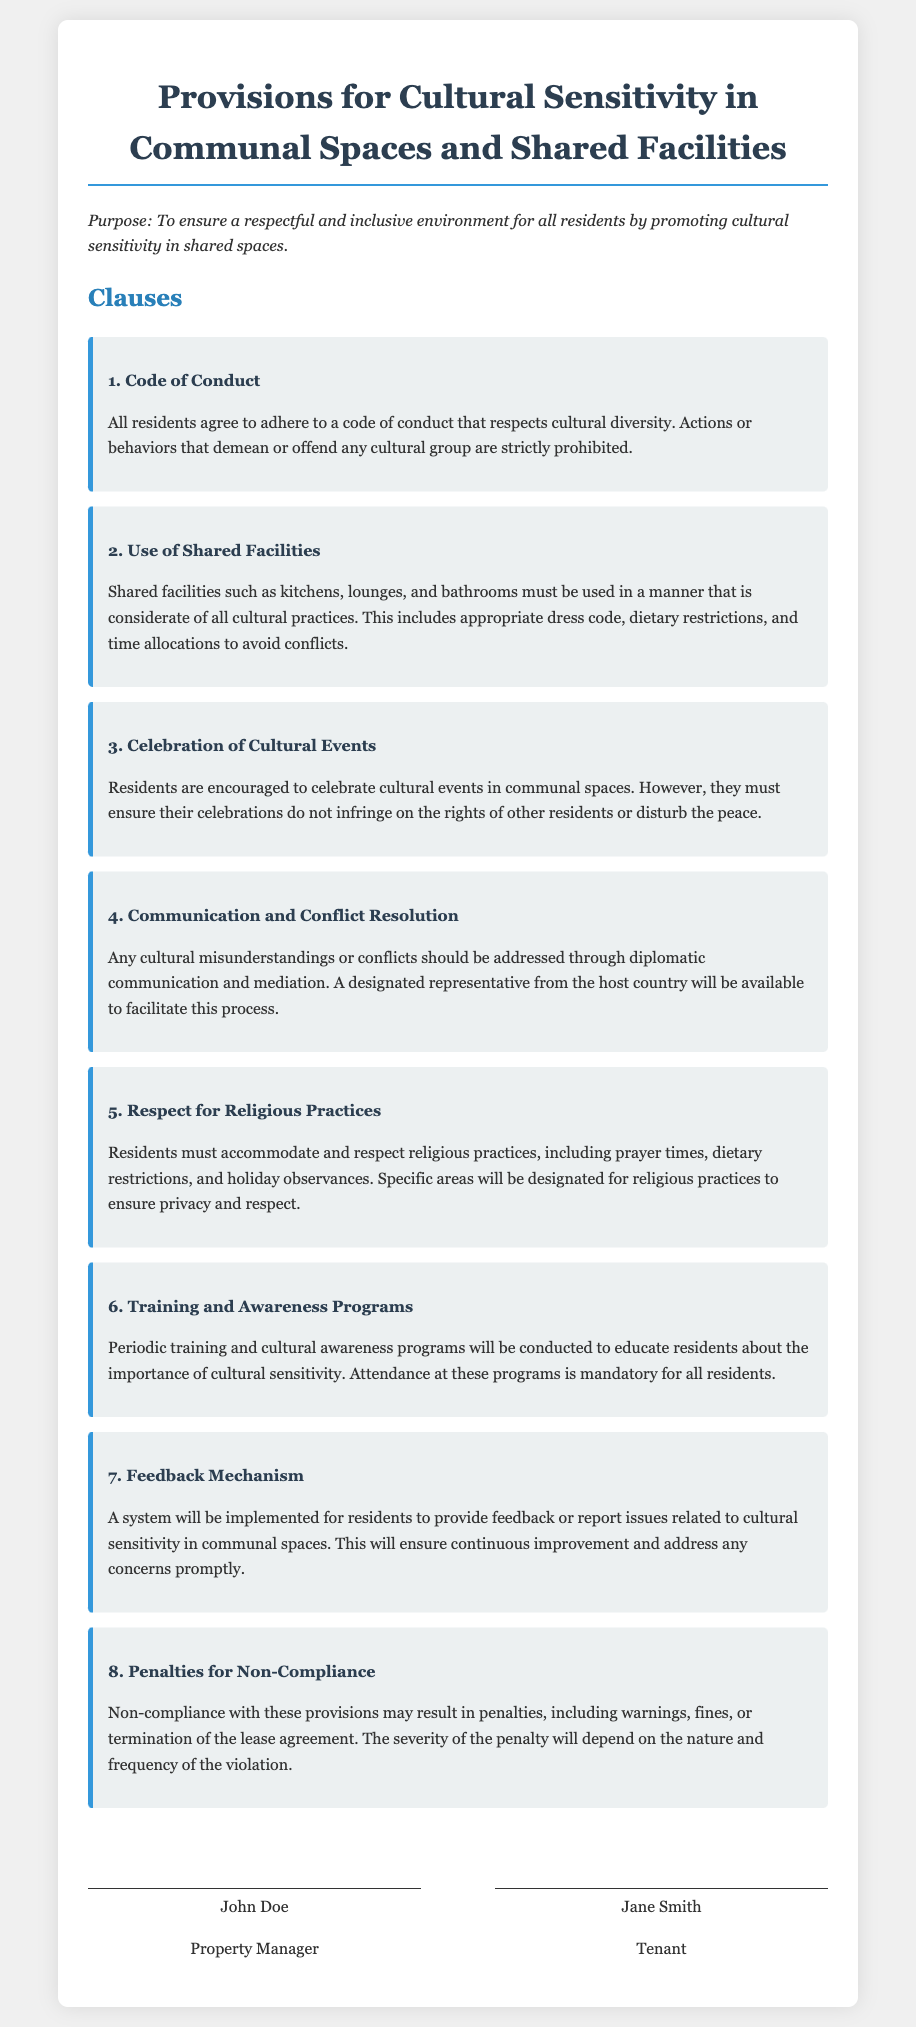What is the purpose of this lease agreement? The purpose is stated in the document as ensuring a respectful and inclusive environment for all residents by promoting cultural sensitivity in shared spaces.
Answer: To ensure a respectful and inclusive environment for all residents by promoting cultural sensitivity in shared spaces How many clauses are there in the document? The number of clauses can be counted in the document, specifically listed under the "Clauses" section.
Answer: 8 What is prohibited under the Code of Conduct? The document specifies that actions or behaviors that demean or offend any cultural group are strictly prohibited.
Answer: Actions or behaviors that demean or offend any cultural group What must be accommodated according to the Respect for Religious Practices clause? This clause mentions that religious practices, including prayer times, dietary restrictions, and holiday observances must be accommodated.
Answer: Religious practices What type of programs will be conducted periodically? The document mentions "periodic training and cultural awareness programs" will be conducted to educate residents.
Answer: Training and awareness programs What penalties may result from non-compliance? The document lists potential penalties for non-compliance, including warnings, fines, or termination of the lease agreement.
Answer: Warnings, fines, or termination of the lease agreement Who will facilitate the communication and conflict resolution? The document states that a designated representative from the host country will be available to facilitate this process.
Answer: A designated representative from the host country What feedback system is mentioned in the document? The document specifies that a system will be implemented for residents to provide feedback or report issues related to cultural sensitivity.
Answer: A system for residents to provide feedback or report issues 